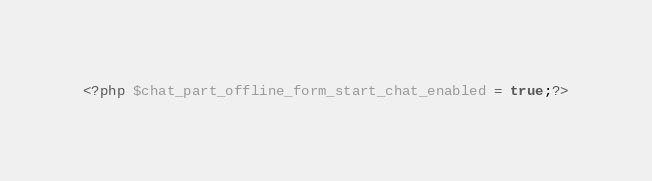<code> <loc_0><loc_0><loc_500><loc_500><_PHP_><?php $chat_part_offline_form_start_chat_enabled = true;?></code> 